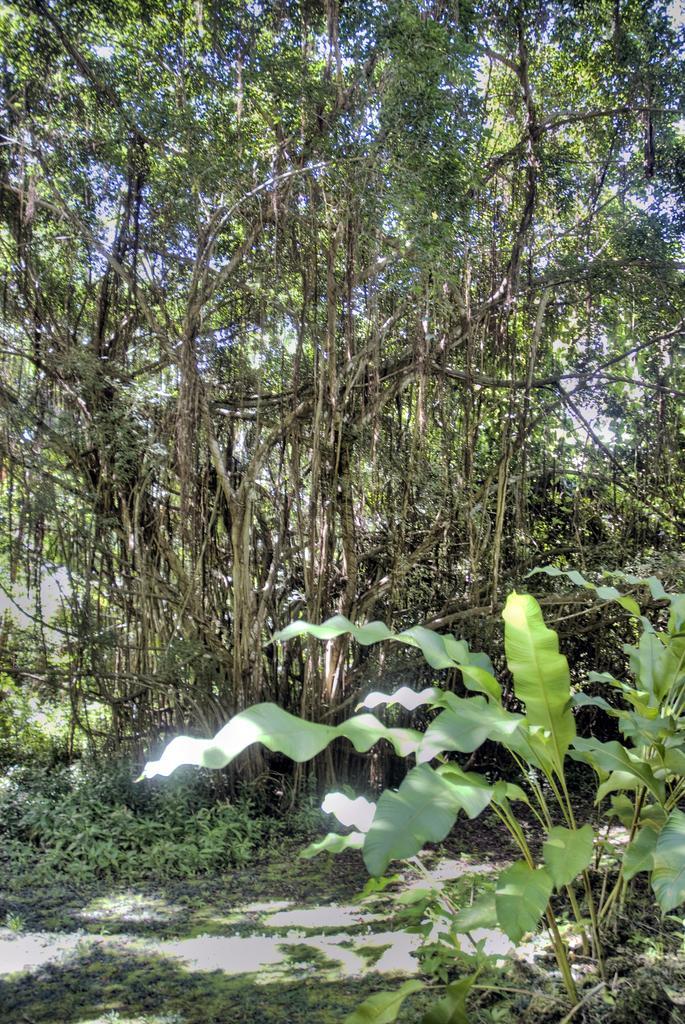Can you describe this image briefly? In the image there are trees on the grassland along with plants all over the place. 